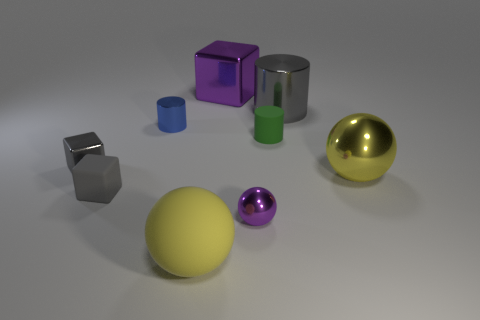What number of blocks are either green matte objects or small yellow metal things?
Provide a short and direct response. 0. How many small gray objects are there?
Your answer should be very brief. 2. There is a matte object right of the shiny ball that is on the left side of the gray cylinder; what is its size?
Provide a succinct answer. Small. What number of other objects are the same size as the blue metal object?
Your response must be concise. 4. What number of yellow metallic things are on the right side of the yellow rubber sphere?
Provide a short and direct response. 1. The purple sphere has what size?
Ensure brevity in your answer.  Small. Are the large yellow ball on the right side of the large matte thing and the yellow sphere on the left side of the gray metallic cylinder made of the same material?
Provide a short and direct response. No. Is there a metal sphere of the same color as the big block?
Provide a succinct answer. Yes. There is a ball that is the same size as the rubber cylinder; what is its color?
Make the answer very short. Purple. There is a big metal thing behind the large shiny cylinder; does it have the same color as the small sphere?
Offer a terse response. Yes. 